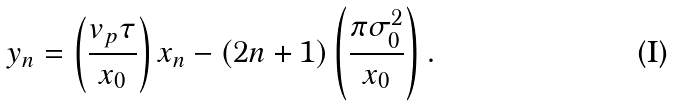Convert formula to latex. <formula><loc_0><loc_0><loc_500><loc_500>y _ { n } = \left ( \frac { v _ { p } \tau } { x _ { 0 } } \right ) x _ { n } - ( 2 n + 1 ) \left ( \frac { \pi \sigma _ { 0 } ^ { 2 } } { x _ { 0 } } \right ) .</formula> 